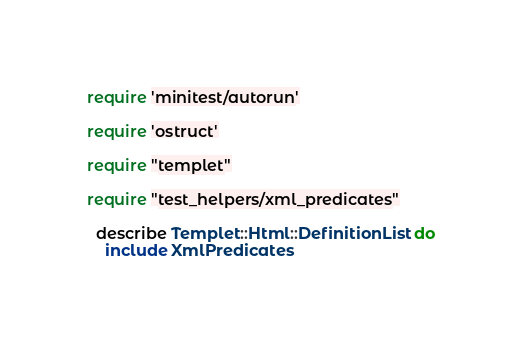Convert code to text. <code><loc_0><loc_0><loc_500><loc_500><_Ruby_>
require 'minitest/autorun'

require 'ostruct'

require "templet"

require "test_helpers/xml_predicates"

  describe Templet::Html::DefinitionList do
    include XmlPredicates
</code> 